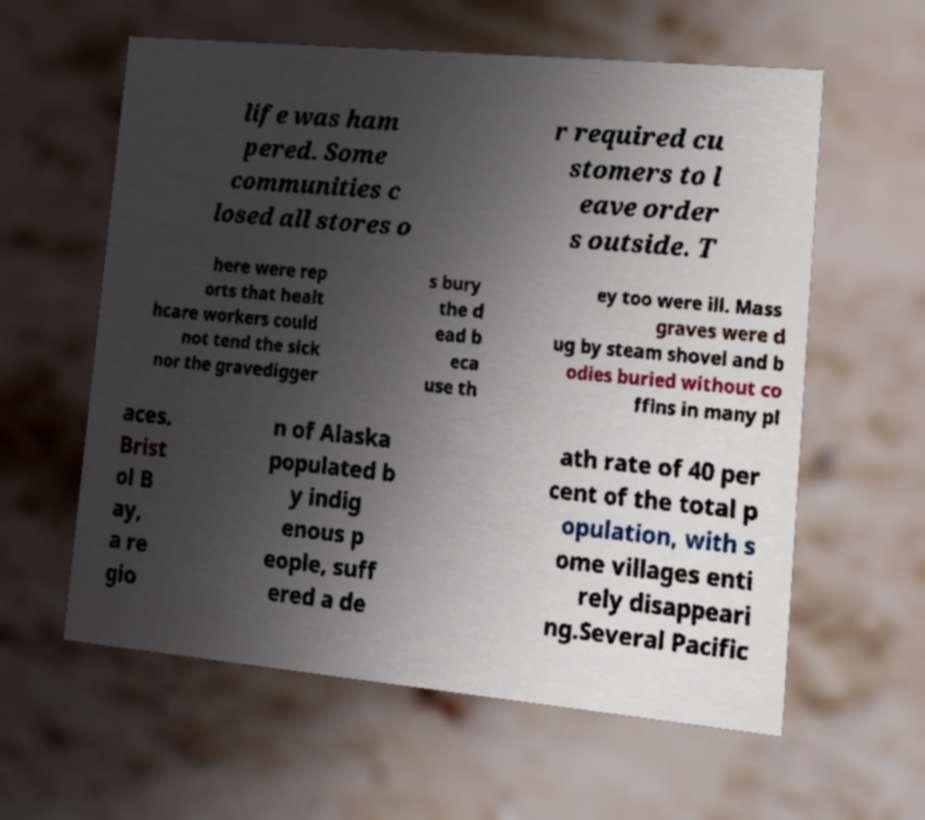There's text embedded in this image that I need extracted. Can you transcribe it verbatim? life was ham pered. Some communities c losed all stores o r required cu stomers to l eave order s outside. T here were rep orts that healt hcare workers could not tend the sick nor the gravedigger s bury the d ead b eca use th ey too were ill. Mass graves were d ug by steam shovel and b odies buried without co ffins in many pl aces. Brist ol B ay, a re gio n of Alaska populated b y indig enous p eople, suff ered a de ath rate of 40 per cent of the total p opulation, with s ome villages enti rely disappeari ng.Several Pacific 